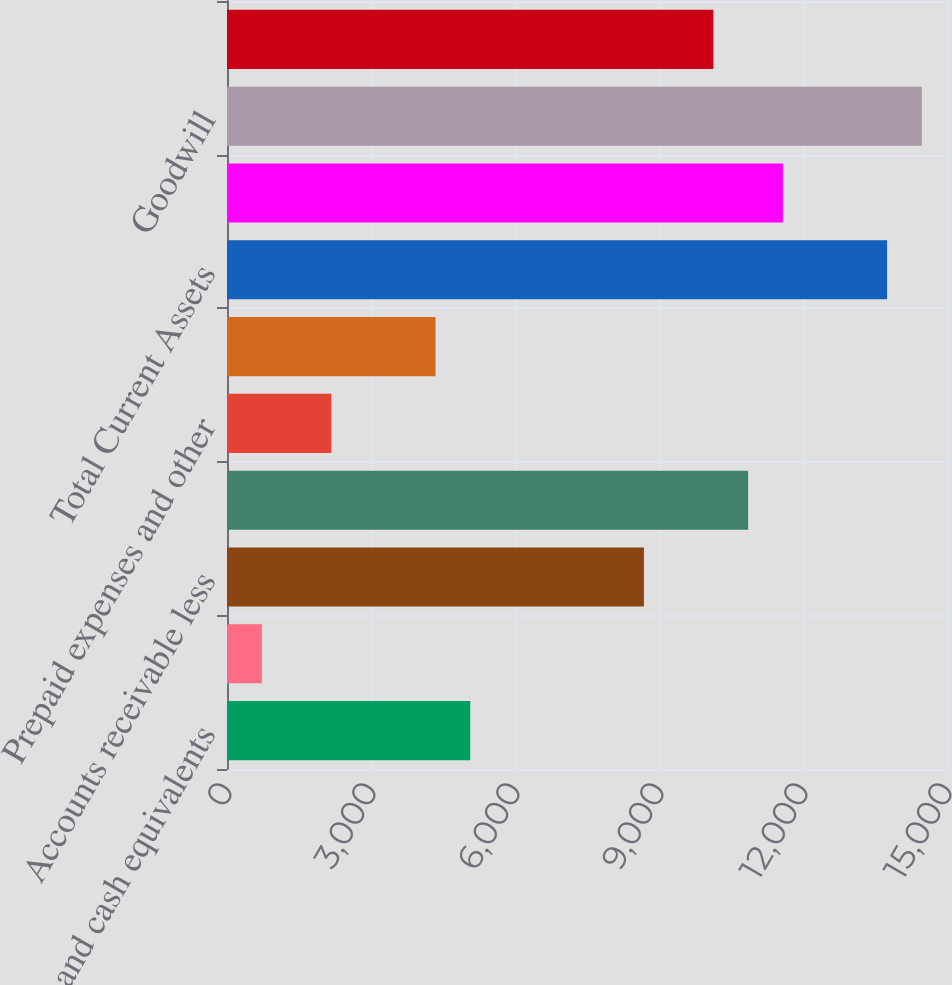Convert chart to OTSL. <chart><loc_0><loc_0><loc_500><loc_500><bar_chart><fcel>Cash and cash equivalents<fcel>Restricted cash<fcel>Accounts receivable less<fcel>Inventories net<fcel>Prepaid expenses and other<fcel>Deferred income taxes<fcel>Total Current Assets<fcel>Property plant and equipment<fcel>Goodwill<fcel>Intangible assets net<nl><fcel>5068.05<fcel>726.15<fcel>8686.3<fcel>10857.2<fcel>2173.45<fcel>4344.4<fcel>13751.9<fcel>11580.9<fcel>14475.5<fcel>10133.6<nl></chart> 